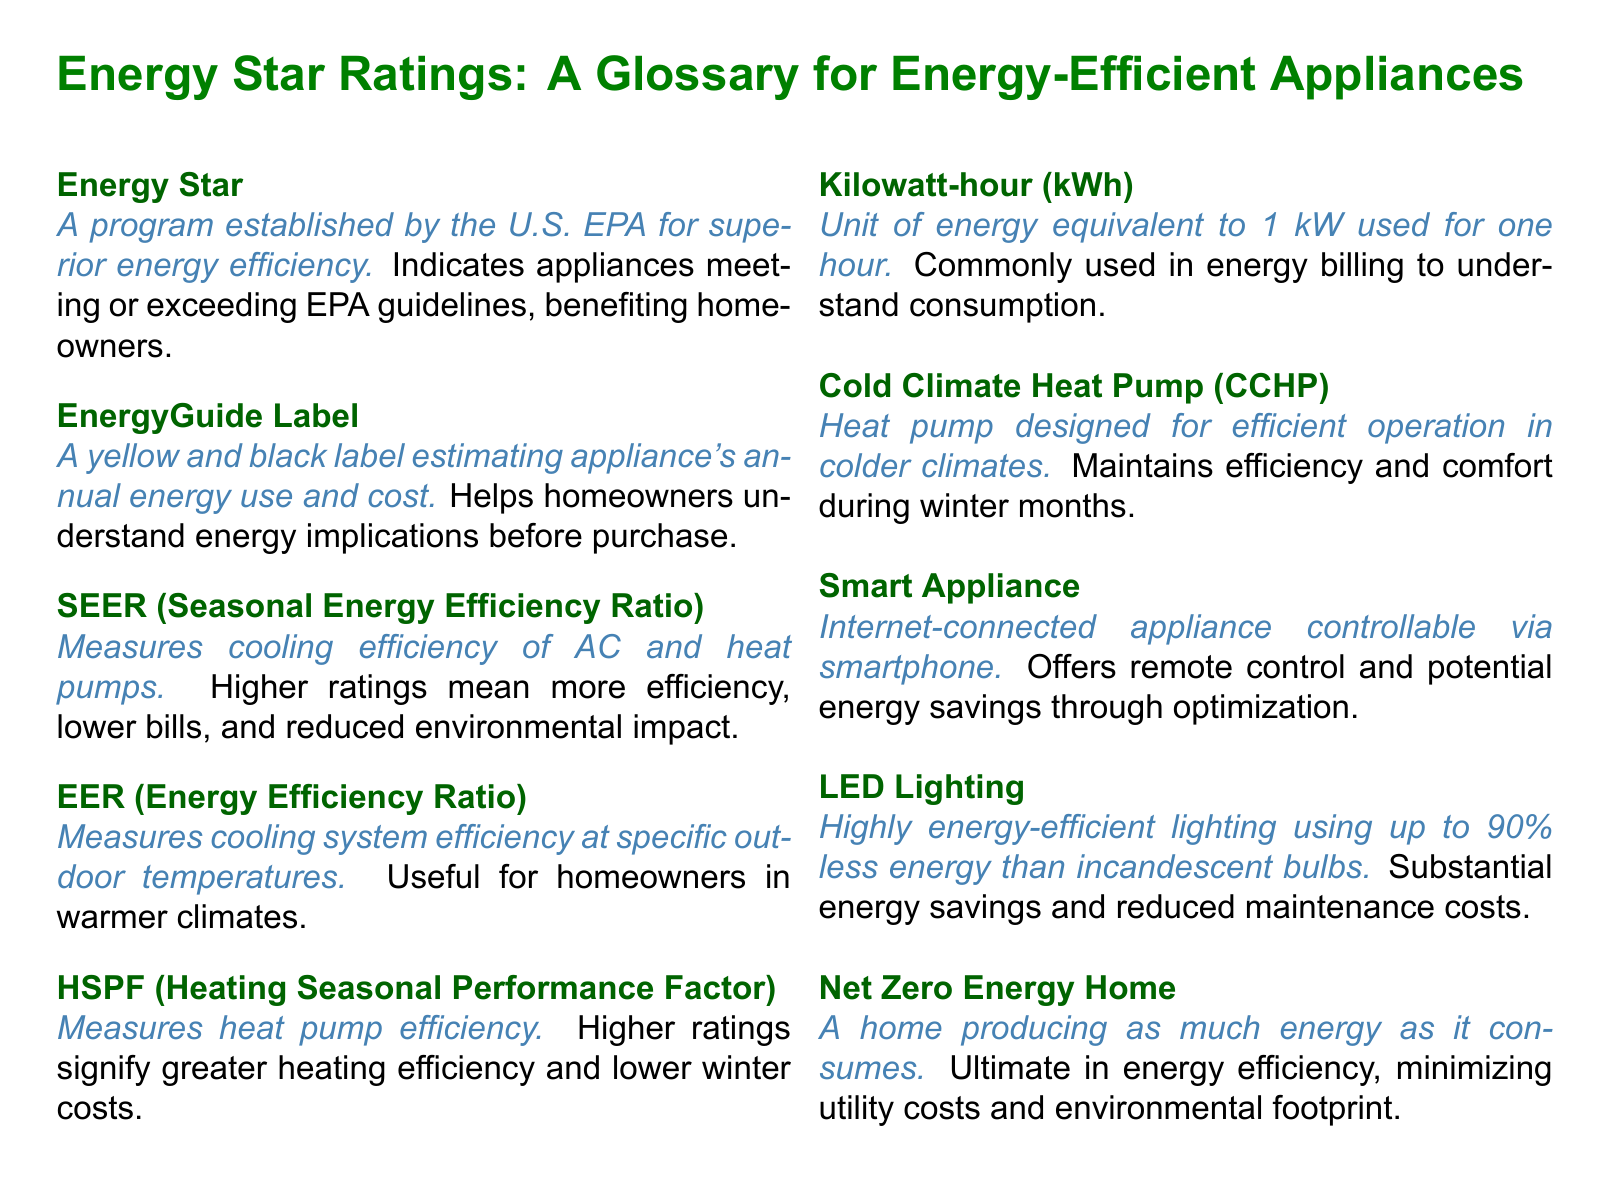What does the Energy Star program indicate? The Energy Star program indicates appliances meeting or exceeding EPA guidelines, benefiting homeowners.
Answer: Appliances meeting or exceeding EPA guidelines What information does the EnergyGuide Label provide? The EnergyGuide Label provides an estimate of the appliance's annual energy use and cost, helping homeowners understand energy implications before purchase.
Answer: Annual energy use and cost What does a higher SEER rating signify? A higher SEER rating signifies more efficiency, lower bills, and reduced environmental impact in cooling systems.
Answer: More efficiency What unit is commonly used in energy billing? The unit commonly used in energy billing is the kilowatt-hour (kWh).
Answer: Kilowatt-hour (kWh) What type of appliance can be controlled via smartphone? A smart appliance is an internet-connected appliance controllable via smartphone.
Answer: Smart appliance What is the definition of a Net Zero Energy Home? A Net Zero Energy Home is defined as a home producing as much energy as it consumes, minimizing utility costs and environmental footprint.
Answer: Producing as much energy as it consumes What does HSPF measure? HSPF measures heat pump efficiency.
Answer: Heat pump efficiency Why are LED lights considered highly energy-efficient? LED lights are considered highly energy-efficient because they use up to 90% less energy than incandescent bulbs.
Answer: Use up to 90% less energy What is a Cold Climate Heat Pump designed for? A Cold Climate Heat Pump is designed for efficient operation in colder climates.
Answer: Efficient operation in colder climates 